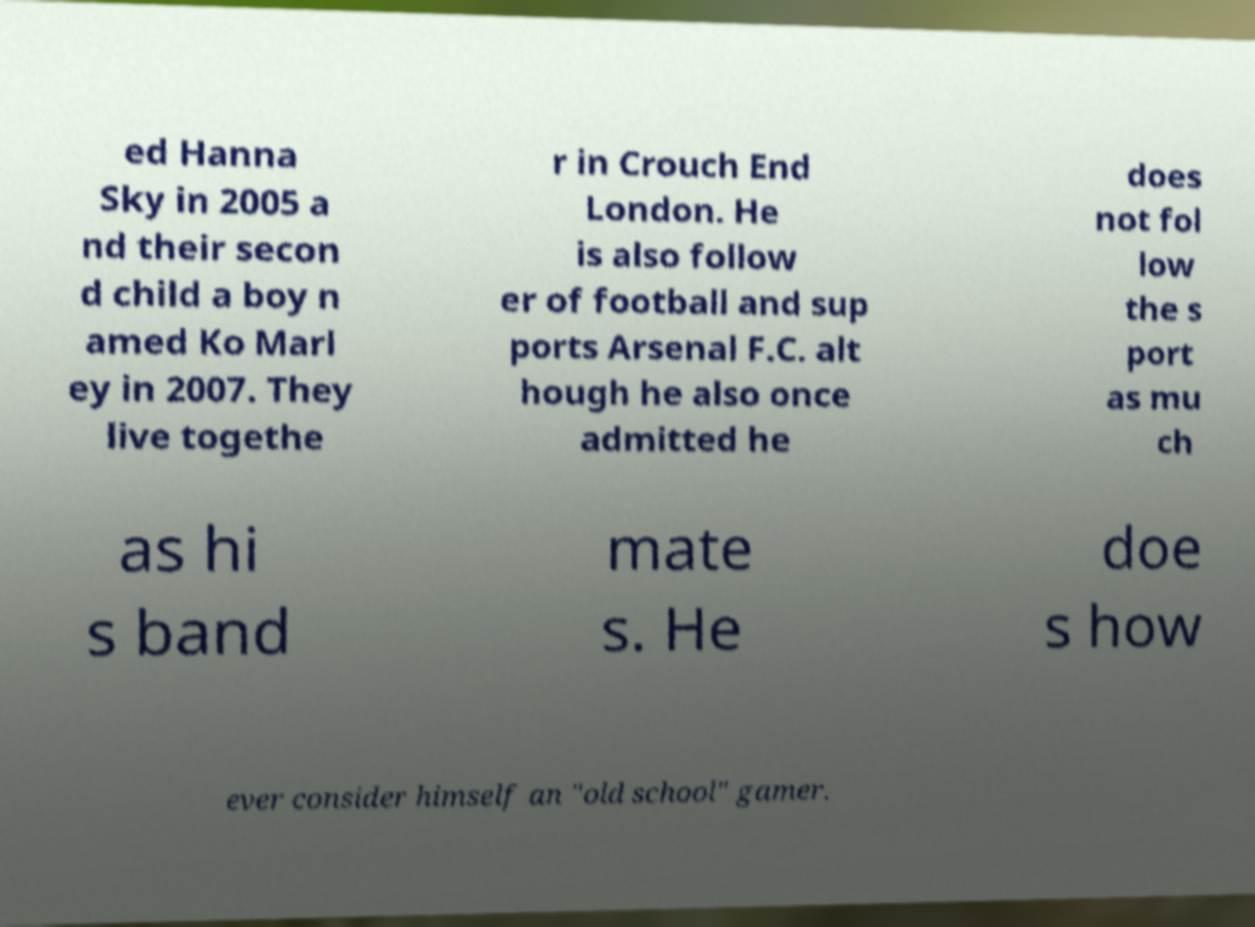Could you assist in decoding the text presented in this image and type it out clearly? ed Hanna Sky in 2005 a nd their secon d child a boy n amed Ko Marl ey in 2007. They live togethe r in Crouch End London. He is also follow er of football and sup ports Arsenal F.C. alt hough he also once admitted he does not fol low the s port as mu ch as hi s band mate s. He doe s how ever consider himself an "old school" gamer. 